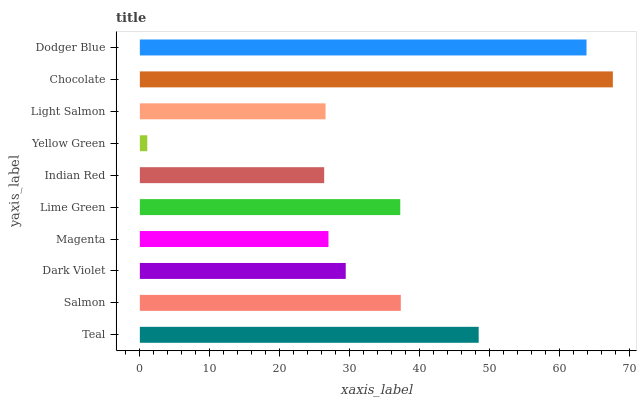Is Yellow Green the minimum?
Answer yes or no. Yes. Is Chocolate the maximum?
Answer yes or no. Yes. Is Salmon the minimum?
Answer yes or no. No. Is Salmon the maximum?
Answer yes or no. No. Is Teal greater than Salmon?
Answer yes or no. Yes. Is Salmon less than Teal?
Answer yes or no. Yes. Is Salmon greater than Teal?
Answer yes or no. No. Is Teal less than Salmon?
Answer yes or no. No. Is Lime Green the high median?
Answer yes or no. Yes. Is Dark Violet the low median?
Answer yes or no. Yes. Is Salmon the high median?
Answer yes or no. No. Is Lime Green the low median?
Answer yes or no. No. 